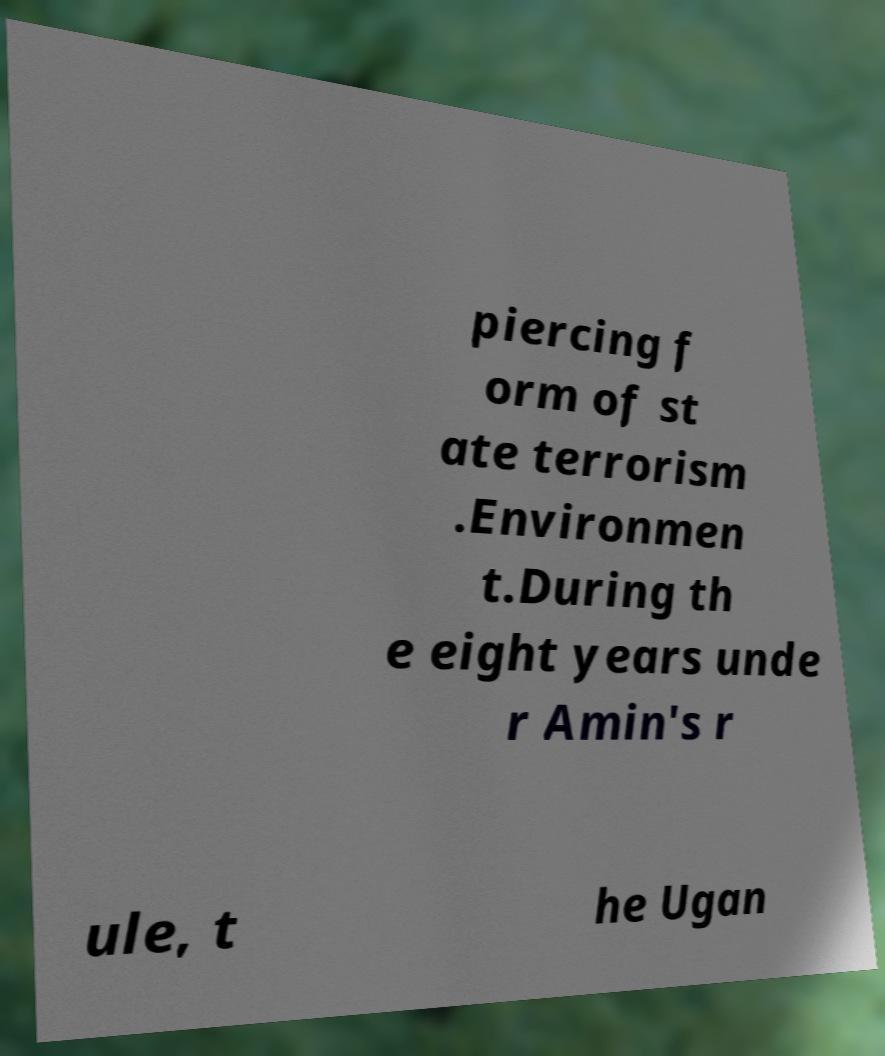For documentation purposes, I need the text within this image transcribed. Could you provide that? piercing f orm of st ate terrorism .Environmen t.During th e eight years unde r Amin's r ule, t he Ugan 